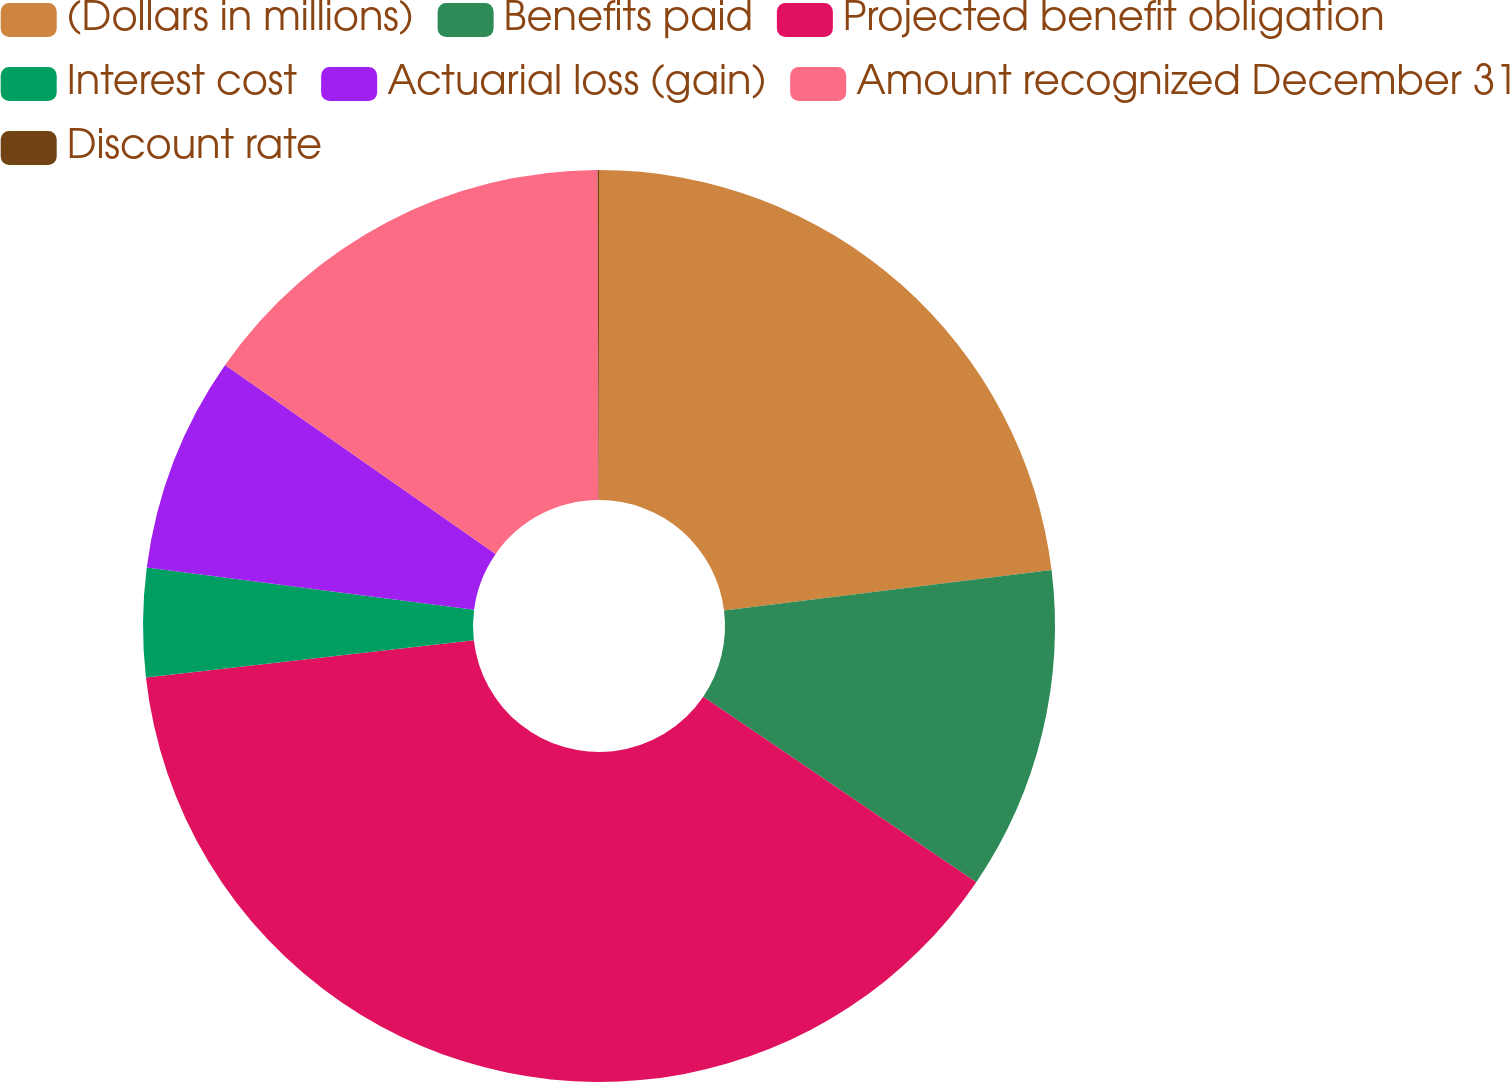Convert chart. <chart><loc_0><loc_0><loc_500><loc_500><pie_chart><fcel>(Dollars in millions)<fcel>Benefits paid<fcel>Projected benefit obligation<fcel>Interest cost<fcel>Actuarial loss (gain)<fcel>Amount recognized December 31<fcel>Discount rate<nl><fcel>23.04%<fcel>11.45%<fcel>38.7%<fcel>3.85%<fcel>7.65%<fcel>15.25%<fcel>0.05%<nl></chart> 